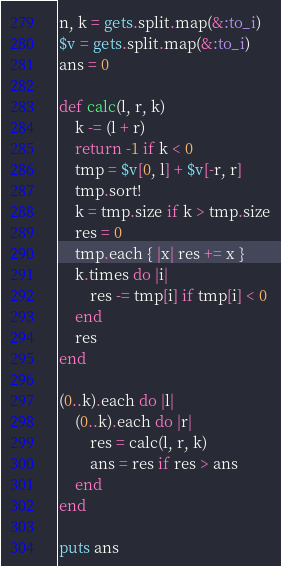Convert code to text. <code><loc_0><loc_0><loc_500><loc_500><_Ruby_>n, k = gets.split.map(&:to_i)
$v = gets.split.map(&:to_i)
ans = 0

def calc(l, r, k)
    k -= (l + r)
    return -1 if k < 0
    tmp = $v[0, l] + $v[-r, r]
    tmp.sort!
    k = tmp.size if k > tmp.size
    res = 0
    tmp.each { |x| res += x }
    k.times do |i|
        res -= tmp[i] if tmp[i] < 0
    end
    res
end

(0..k).each do |l|
    (0..k).each do |r|
        res = calc(l, r, k)
        ans = res if res > ans
    end
end

puts ans</code> 